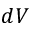<formula> <loc_0><loc_0><loc_500><loc_500>d V</formula> 